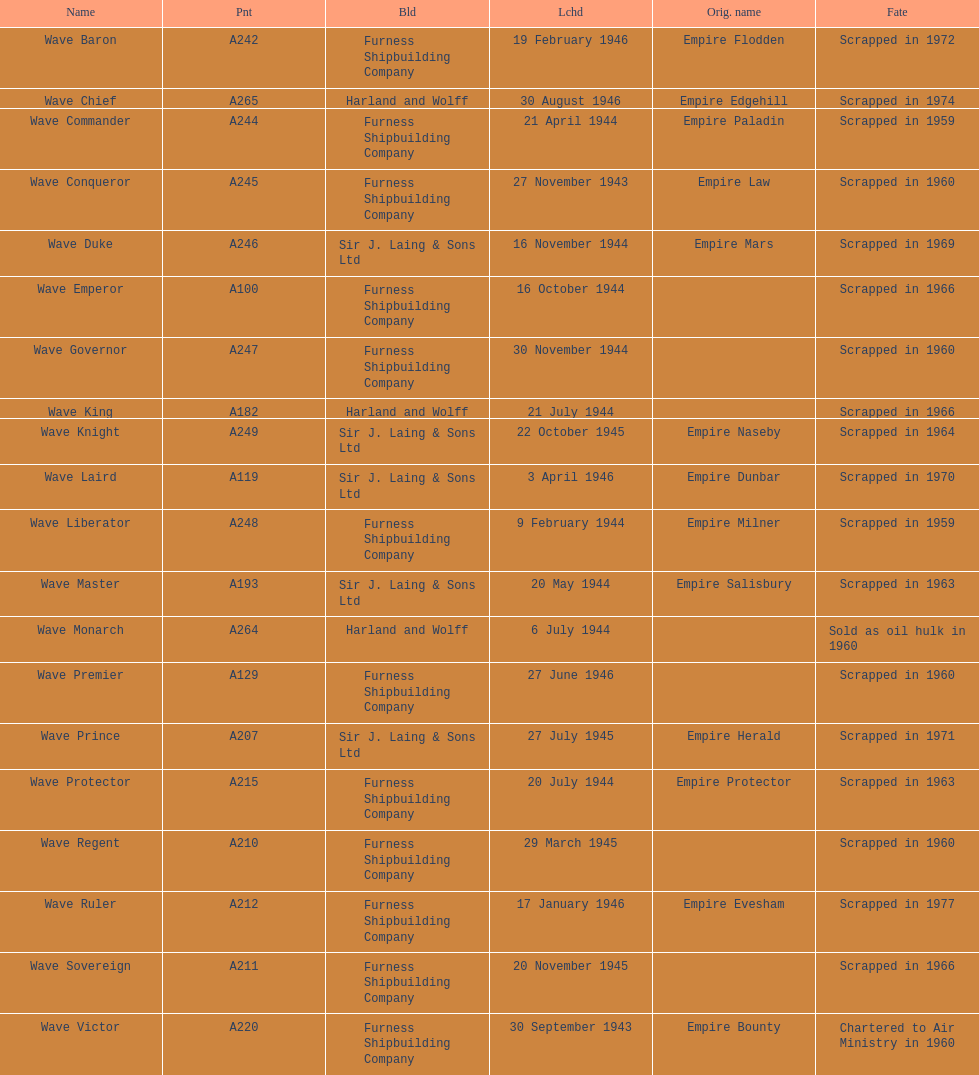What is the name of the last ship that was scrapped? Wave Ruler. 